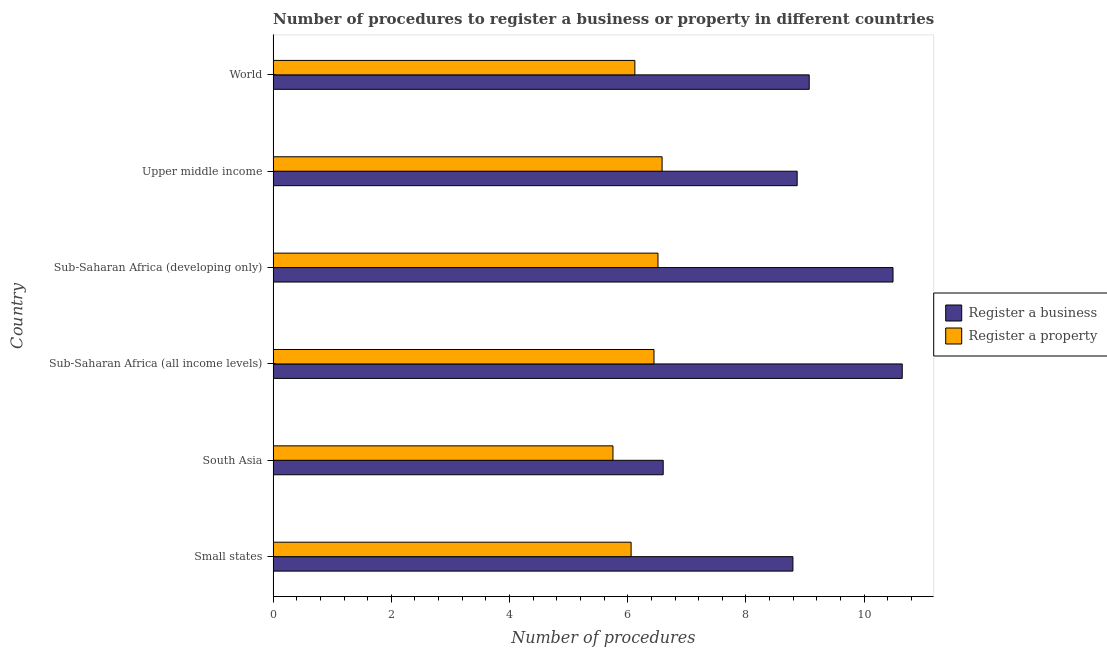How many different coloured bars are there?
Offer a terse response. 2. How many groups of bars are there?
Offer a very short reply. 6. Are the number of bars per tick equal to the number of legend labels?
Offer a very short reply. Yes. Are the number of bars on each tick of the Y-axis equal?
Make the answer very short. Yes. How many bars are there on the 4th tick from the top?
Ensure brevity in your answer.  2. How many bars are there on the 3rd tick from the bottom?
Offer a terse response. 2. What is the label of the 5th group of bars from the top?
Keep it short and to the point. South Asia. Across all countries, what is the maximum number of procedures to register a business?
Your answer should be compact. 10.64. Across all countries, what is the minimum number of procedures to register a business?
Your answer should be very brief. 6.6. In which country was the number of procedures to register a business maximum?
Provide a succinct answer. Sub-Saharan Africa (all income levels). What is the total number of procedures to register a property in the graph?
Ensure brevity in your answer.  37.47. What is the difference between the number of procedures to register a business in Sub-Saharan Africa (all income levels) and that in Upper middle income?
Ensure brevity in your answer.  1.78. What is the difference between the number of procedures to register a business in Sub-Saharan Africa (all income levels) and the number of procedures to register a property in Small states?
Provide a short and direct response. 4.59. What is the average number of procedures to register a business per country?
Provide a short and direct response. 9.08. What is the difference between the number of procedures to register a business and number of procedures to register a property in Upper middle income?
Keep it short and to the point. 2.29. In how many countries, is the number of procedures to register a property greater than 0.4 ?
Your answer should be compact. 6. What is the ratio of the number of procedures to register a business in Sub-Saharan Africa (developing only) to that in World?
Make the answer very short. 1.16. Is the number of procedures to register a business in Sub-Saharan Africa (all income levels) less than that in Sub-Saharan Africa (developing only)?
Ensure brevity in your answer.  No. Is the difference between the number of procedures to register a business in Sub-Saharan Africa (all income levels) and World greater than the difference between the number of procedures to register a property in Sub-Saharan Africa (all income levels) and World?
Offer a terse response. Yes. What is the difference between the highest and the second highest number of procedures to register a business?
Provide a short and direct response. 0.16. What is the difference between the highest and the lowest number of procedures to register a business?
Provide a succinct answer. 4.04. What does the 1st bar from the top in World represents?
Keep it short and to the point. Register a property. What does the 2nd bar from the bottom in Sub-Saharan Africa (developing only) represents?
Ensure brevity in your answer.  Register a property. How many countries are there in the graph?
Keep it short and to the point. 6. Does the graph contain any zero values?
Your answer should be compact. No. How many legend labels are there?
Provide a short and direct response. 2. What is the title of the graph?
Your answer should be very brief. Number of procedures to register a business or property in different countries. What is the label or title of the X-axis?
Ensure brevity in your answer.  Number of procedures. What is the label or title of the Y-axis?
Your response must be concise. Country. What is the Number of procedures in Register a business in Small states?
Ensure brevity in your answer.  8.79. What is the Number of procedures in Register a property in Small states?
Keep it short and to the point. 6.06. What is the Number of procedures of Register a business in South Asia?
Ensure brevity in your answer.  6.6. What is the Number of procedures in Register a property in South Asia?
Keep it short and to the point. 5.75. What is the Number of procedures of Register a business in Sub-Saharan Africa (all income levels)?
Your answer should be compact. 10.64. What is the Number of procedures in Register a property in Sub-Saharan Africa (all income levels)?
Offer a terse response. 6.44. What is the Number of procedures in Register a business in Sub-Saharan Africa (developing only)?
Offer a terse response. 10.49. What is the Number of procedures of Register a property in Sub-Saharan Africa (developing only)?
Your answer should be very brief. 6.51. What is the Number of procedures in Register a business in Upper middle income?
Your response must be concise. 8.87. What is the Number of procedures of Register a property in Upper middle income?
Your answer should be compact. 6.58. What is the Number of procedures of Register a business in World?
Offer a very short reply. 9.07. What is the Number of procedures in Register a property in World?
Give a very brief answer. 6.12. Across all countries, what is the maximum Number of procedures in Register a business?
Your answer should be compact. 10.64. Across all countries, what is the maximum Number of procedures in Register a property?
Offer a very short reply. 6.58. Across all countries, what is the minimum Number of procedures of Register a property?
Offer a very short reply. 5.75. What is the total Number of procedures of Register a business in the graph?
Give a very brief answer. 54.46. What is the total Number of procedures in Register a property in the graph?
Your response must be concise. 37.47. What is the difference between the Number of procedures in Register a business in Small states and that in South Asia?
Keep it short and to the point. 2.19. What is the difference between the Number of procedures of Register a property in Small states and that in South Asia?
Provide a succinct answer. 0.31. What is the difference between the Number of procedures of Register a business in Small states and that in Sub-Saharan Africa (all income levels)?
Keep it short and to the point. -1.85. What is the difference between the Number of procedures of Register a property in Small states and that in Sub-Saharan Africa (all income levels)?
Make the answer very short. -0.39. What is the difference between the Number of procedures in Register a business in Small states and that in Sub-Saharan Africa (developing only)?
Provide a short and direct response. -1.69. What is the difference between the Number of procedures of Register a property in Small states and that in Sub-Saharan Africa (developing only)?
Your answer should be compact. -0.45. What is the difference between the Number of procedures in Register a business in Small states and that in Upper middle income?
Make the answer very short. -0.07. What is the difference between the Number of procedures in Register a property in Small states and that in Upper middle income?
Ensure brevity in your answer.  -0.52. What is the difference between the Number of procedures of Register a business in Small states and that in World?
Your answer should be compact. -0.28. What is the difference between the Number of procedures in Register a property in Small states and that in World?
Provide a succinct answer. -0.06. What is the difference between the Number of procedures in Register a business in South Asia and that in Sub-Saharan Africa (all income levels)?
Your response must be concise. -4.04. What is the difference between the Number of procedures in Register a property in South Asia and that in Sub-Saharan Africa (all income levels)?
Offer a terse response. -0.69. What is the difference between the Number of procedures of Register a business in South Asia and that in Sub-Saharan Africa (developing only)?
Give a very brief answer. -3.89. What is the difference between the Number of procedures in Register a property in South Asia and that in Sub-Saharan Africa (developing only)?
Provide a short and direct response. -0.76. What is the difference between the Number of procedures in Register a business in South Asia and that in Upper middle income?
Provide a succinct answer. -2.27. What is the difference between the Number of procedures in Register a property in South Asia and that in Upper middle income?
Offer a terse response. -0.83. What is the difference between the Number of procedures in Register a business in South Asia and that in World?
Ensure brevity in your answer.  -2.47. What is the difference between the Number of procedures in Register a property in South Asia and that in World?
Provide a succinct answer. -0.37. What is the difference between the Number of procedures in Register a business in Sub-Saharan Africa (all income levels) and that in Sub-Saharan Africa (developing only)?
Your answer should be very brief. 0.16. What is the difference between the Number of procedures of Register a property in Sub-Saharan Africa (all income levels) and that in Sub-Saharan Africa (developing only)?
Provide a succinct answer. -0.07. What is the difference between the Number of procedures in Register a business in Sub-Saharan Africa (all income levels) and that in Upper middle income?
Your answer should be compact. 1.78. What is the difference between the Number of procedures of Register a property in Sub-Saharan Africa (all income levels) and that in Upper middle income?
Keep it short and to the point. -0.14. What is the difference between the Number of procedures of Register a business in Sub-Saharan Africa (all income levels) and that in World?
Offer a very short reply. 1.57. What is the difference between the Number of procedures of Register a property in Sub-Saharan Africa (all income levels) and that in World?
Offer a terse response. 0.32. What is the difference between the Number of procedures of Register a business in Sub-Saharan Africa (developing only) and that in Upper middle income?
Keep it short and to the point. 1.62. What is the difference between the Number of procedures in Register a property in Sub-Saharan Africa (developing only) and that in Upper middle income?
Provide a succinct answer. -0.07. What is the difference between the Number of procedures in Register a business in Sub-Saharan Africa (developing only) and that in World?
Make the answer very short. 1.42. What is the difference between the Number of procedures in Register a property in Sub-Saharan Africa (developing only) and that in World?
Offer a very short reply. 0.39. What is the difference between the Number of procedures of Register a business in Upper middle income and that in World?
Offer a very short reply. -0.2. What is the difference between the Number of procedures in Register a property in Upper middle income and that in World?
Keep it short and to the point. 0.46. What is the difference between the Number of procedures of Register a business in Small states and the Number of procedures of Register a property in South Asia?
Your response must be concise. 3.04. What is the difference between the Number of procedures in Register a business in Small states and the Number of procedures in Register a property in Sub-Saharan Africa (all income levels)?
Offer a very short reply. 2.35. What is the difference between the Number of procedures in Register a business in Small states and the Number of procedures in Register a property in Sub-Saharan Africa (developing only)?
Ensure brevity in your answer.  2.28. What is the difference between the Number of procedures in Register a business in Small states and the Number of procedures in Register a property in Upper middle income?
Offer a very short reply. 2.21. What is the difference between the Number of procedures in Register a business in Small states and the Number of procedures in Register a property in World?
Give a very brief answer. 2.67. What is the difference between the Number of procedures in Register a business in South Asia and the Number of procedures in Register a property in Sub-Saharan Africa (all income levels)?
Keep it short and to the point. 0.16. What is the difference between the Number of procedures of Register a business in South Asia and the Number of procedures of Register a property in Sub-Saharan Africa (developing only)?
Your response must be concise. 0.09. What is the difference between the Number of procedures of Register a business in South Asia and the Number of procedures of Register a property in Upper middle income?
Your answer should be compact. 0.02. What is the difference between the Number of procedures in Register a business in South Asia and the Number of procedures in Register a property in World?
Offer a very short reply. 0.48. What is the difference between the Number of procedures of Register a business in Sub-Saharan Africa (all income levels) and the Number of procedures of Register a property in Sub-Saharan Africa (developing only)?
Offer a terse response. 4.13. What is the difference between the Number of procedures in Register a business in Sub-Saharan Africa (all income levels) and the Number of procedures in Register a property in Upper middle income?
Keep it short and to the point. 4.06. What is the difference between the Number of procedures in Register a business in Sub-Saharan Africa (all income levels) and the Number of procedures in Register a property in World?
Your response must be concise. 4.52. What is the difference between the Number of procedures in Register a business in Sub-Saharan Africa (developing only) and the Number of procedures in Register a property in Upper middle income?
Your answer should be compact. 3.91. What is the difference between the Number of procedures of Register a business in Sub-Saharan Africa (developing only) and the Number of procedures of Register a property in World?
Provide a short and direct response. 4.37. What is the difference between the Number of procedures of Register a business in Upper middle income and the Number of procedures of Register a property in World?
Provide a succinct answer. 2.75. What is the average Number of procedures in Register a business per country?
Your response must be concise. 9.08. What is the average Number of procedures in Register a property per country?
Your answer should be very brief. 6.24. What is the difference between the Number of procedures in Register a business and Number of procedures in Register a property in Small states?
Your response must be concise. 2.74. What is the difference between the Number of procedures of Register a business and Number of procedures of Register a property in Sub-Saharan Africa (developing only)?
Ensure brevity in your answer.  3.98. What is the difference between the Number of procedures in Register a business and Number of procedures in Register a property in Upper middle income?
Keep it short and to the point. 2.29. What is the difference between the Number of procedures of Register a business and Number of procedures of Register a property in World?
Keep it short and to the point. 2.95. What is the ratio of the Number of procedures in Register a business in Small states to that in South Asia?
Your answer should be very brief. 1.33. What is the ratio of the Number of procedures in Register a property in Small states to that in South Asia?
Give a very brief answer. 1.05. What is the ratio of the Number of procedures in Register a business in Small states to that in Sub-Saharan Africa (all income levels)?
Your response must be concise. 0.83. What is the ratio of the Number of procedures in Register a property in Small states to that in Sub-Saharan Africa (all income levels)?
Your answer should be very brief. 0.94. What is the ratio of the Number of procedures of Register a business in Small states to that in Sub-Saharan Africa (developing only)?
Make the answer very short. 0.84. What is the ratio of the Number of procedures of Register a property in Small states to that in Sub-Saharan Africa (developing only)?
Provide a succinct answer. 0.93. What is the ratio of the Number of procedures of Register a business in Small states to that in Upper middle income?
Give a very brief answer. 0.99. What is the ratio of the Number of procedures of Register a property in Small states to that in Upper middle income?
Offer a very short reply. 0.92. What is the ratio of the Number of procedures of Register a business in Small states to that in World?
Your response must be concise. 0.97. What is the ratio of the Number of procedures in Register a business in South Asia to that in Sub-Saharan Africa (all income levels)?
Make the answer very short. 0.62. What is the ratio of the Number of procedures of Register a property in South Asia to that in Sub-Saharan Africa (all income levels)?
Ensure brevity in your answer.  0.89. What is the ratio of the Number of procedures of Register a business in South Asia to that in Sub-Saharan Africa (developing only)?
Ensure brevity in your answer.  0.63. What is the ratio of the Number of procedures in Register a property in South Asia to that in Sub-Saharan Africa (developing only)?
Make the answer very short. 0.88. What is the ratio of the Number of procedures in Register a business in South Asia to that in Upper middle income?
Provide a short and direct response. 0.74. What is the ratio of the Number of procedures in Register a property in South Asia to that in Upper middle income?
Offer a very short reply. 0.87. What is the ratio of the Number of procedures in Register a business in South Asia to that in World?
Offer a terse response. 0.73. What is the ratio of the Number of procedures of Register a property in South Asia to that in World?
Give a very brief answer. 0.94. What is the ratio of the Number of procedures in Register a business in Sub-Saharan Africa (all income levels) to that in Sub-Saharan Africa (developing only)?
Your answer should be compact. 1.01. What is the ratio of the Number of procedures in Register a property in Sub-Saharan Africa (all income levels) to that in Sub-Saharan Africa (developing only)?
Your answer should be very brief. 0.99. What is the ratio of the Number of procedures of Register a business in Sub-Saharan Africa (all income levels) to that in Upper middle income?
Offer a terse response. 1.2. What is the ratio of the Number of procedures in Register a property in Sub-Saharan Africa (all income levels) to that in Upper middle income?
Make the answer very short. 0.98. What is the ratio of the Number of procedures in Register a business in Sub-Saharan Africa (all income levels) to that in World?
Your answer should be compact. 1.17. What is the ratio of the Number of procedures in Register a property in Sub-Saharan Africa (all income levels) to that in World?
Give a very brief answer. 1.05. What is the ratio of the Number of procedures in Register a business in Sub-Saharan Africa (developing only) to that in Upper middle income?
Your answer should be compact. 1.18. What is the ratio of the Number of procedures in Register a business in Sub-Saharan Africa (developing only) to that in World?
Your answer should be very brief. 1.16. What is the ratio of the Number of procedures of Register a property in Sub-Saharan Africa (developing only) to that in World?
Provide a succinct answer. 1.06. What is the ratio of the Number of procedures of Register a business in Upper middle income to that in World?
Give a very brief answer. 0.98. What is the ratio of the Number of procedures in Register a property in Upper middle income to that in World?
Provide a short and direct response. 1.08. What is the difference between the highest and the second highest Number of procedures of Register a business?
Your answer should be compact. 0.16. What is the difference between the highest and the second highest Number of procedures of Register a property?
Offer a very short reply. 0.07. What is the difference between the highest and the lowest Number of procedures in Register a business?
Offer a very short reply. 4.04. What is the difference between the highest and the lowest Number of procedures in Register a property?
Your answer should be very brief. 0.83. 